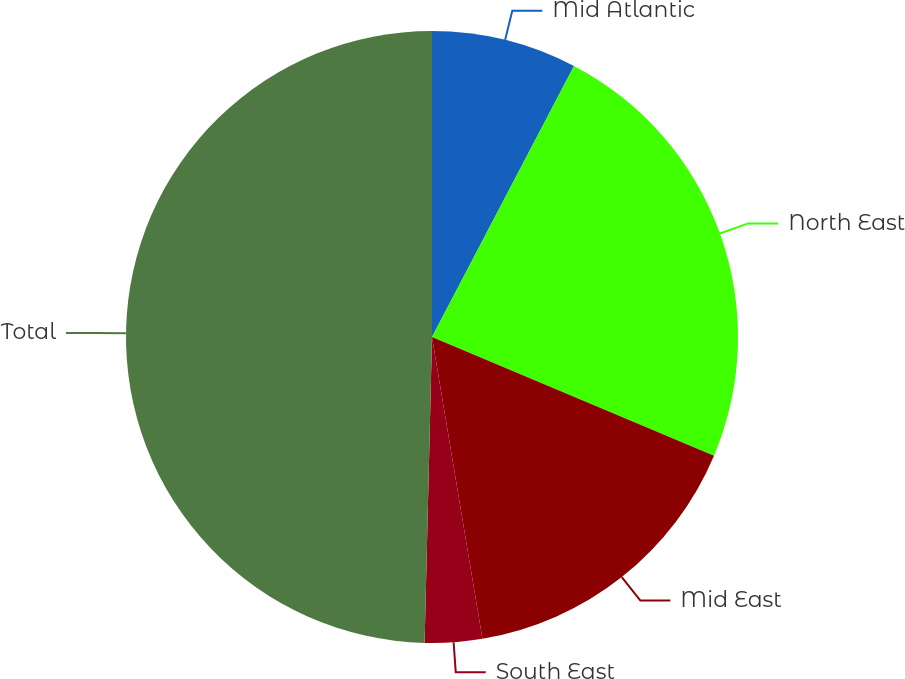Convert chart. <chart><loc_0><loc_0><loc_500><loc_500><pie_chart><fcel>Mid Atlantic<fcel>North East<fcel>Mid East<fcel>South East<fcel>Total<nl><fcel>7.68%<fcel>23.66%<fcel>16.02%<fcel>3.02%<fcel>49.61%<nl></chart> 